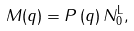<formula> <loc_0><loc_0><loc_500><loc_500>M ( q ) = P \left ( q \right ) N _ { 0 } ^ { \text {L} } ,</formula> 